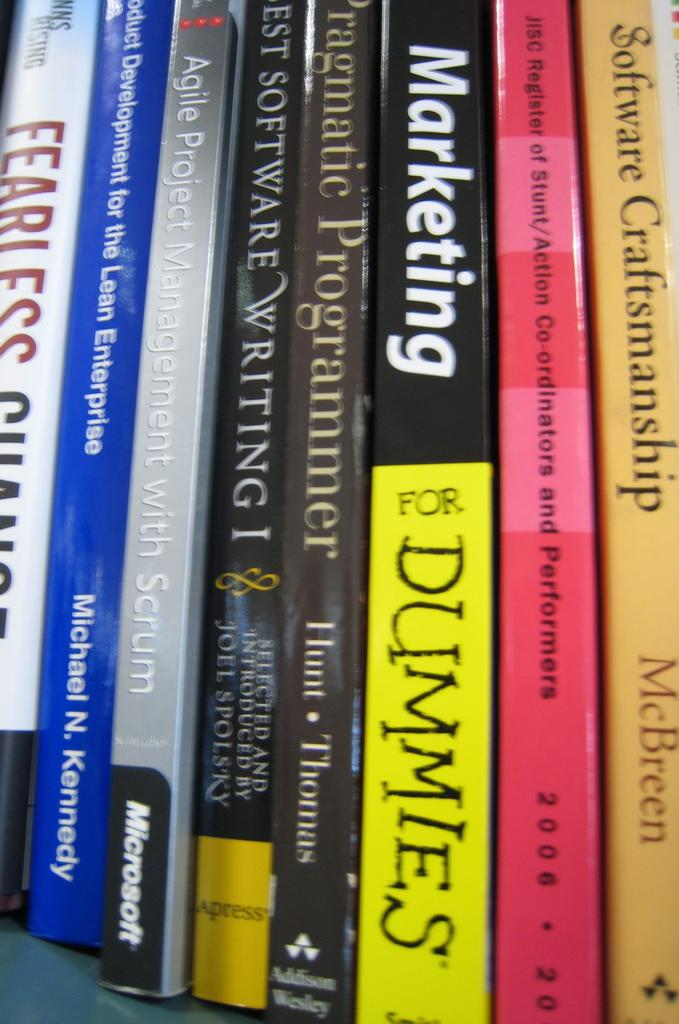What type of objects can be seen in the image? There are books in the image. Can you describe the books in more detail? Unfortunately, the provided facts do not offer more details about the books. Are the books the only objects present in the image? The provided facts do not mention any other objects in the image. What color is the scarf wrapped around the can in the image? There is no can or scarf present in the image; it only features books. 